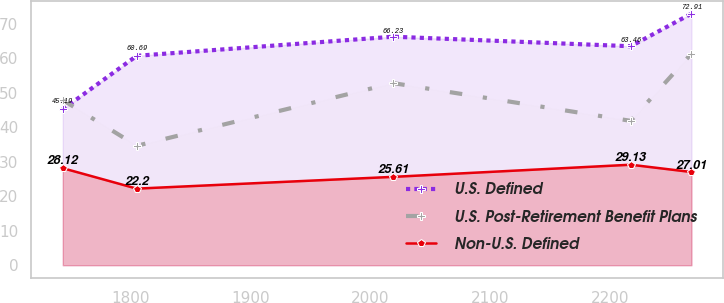Convert chart. <chart><loc_0><loc_0><loc_500><loc_500><line_chart><ecel><fcel>U.S. Defined<fcel>U.S. Post-Retirement Benefit Plans<fcel>Non-U.S. Defined<nl><fcel>1743.12<fcel>45.19<fcel>47.88<fcel>28.12<nl><fcel>1804.88<fcel>60.69<fcel>34.62<fcel>22.2<nl><fcel>2019.02<fcel>66.23<fcel>52.78<fcel>25.61<nl><fcel>2217.42<fcel>63.46<fcel>41.84<fcel>29.13<nl><fcel>2268.12<fcel>72.91<fcel>61.33<fcel>27.01<nl></chart> 